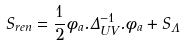<formula> <loc_0><loc_0><loc_500><loc_500>S _ { r e n } = \frac { 1 } { 2 } \phi _ { a } . \Delta ^ { - 1 } _ { U V } . \phi _ { a } + S _ { \Lambda }</formula> 